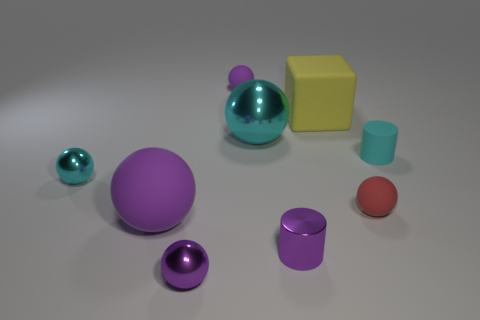Subtract all purple spheres. How many were subtracted if there are1purple spheres left? 2 Subtract all green cubes. How many cyan balls are left? 2 Subtract all cyan balls. How many balls are left? 4 Subtract 2 balls. How many balls are left? 4 Subtract all purple spheres. How many spheres are left? 3 Subtract all blocks. How many objects are left? 8 Add 2 tiny shiny cylinders. How many tiny shiny cylinders are left? 3 Add 2 big cyan metal balls. How many big cyan metal balls exist? 3 Subtract 2 cyan balls. How many objects are left? 7 Subtract all yellow cylinders. Subtract all blue cubes. How many cylinders are left? 2 